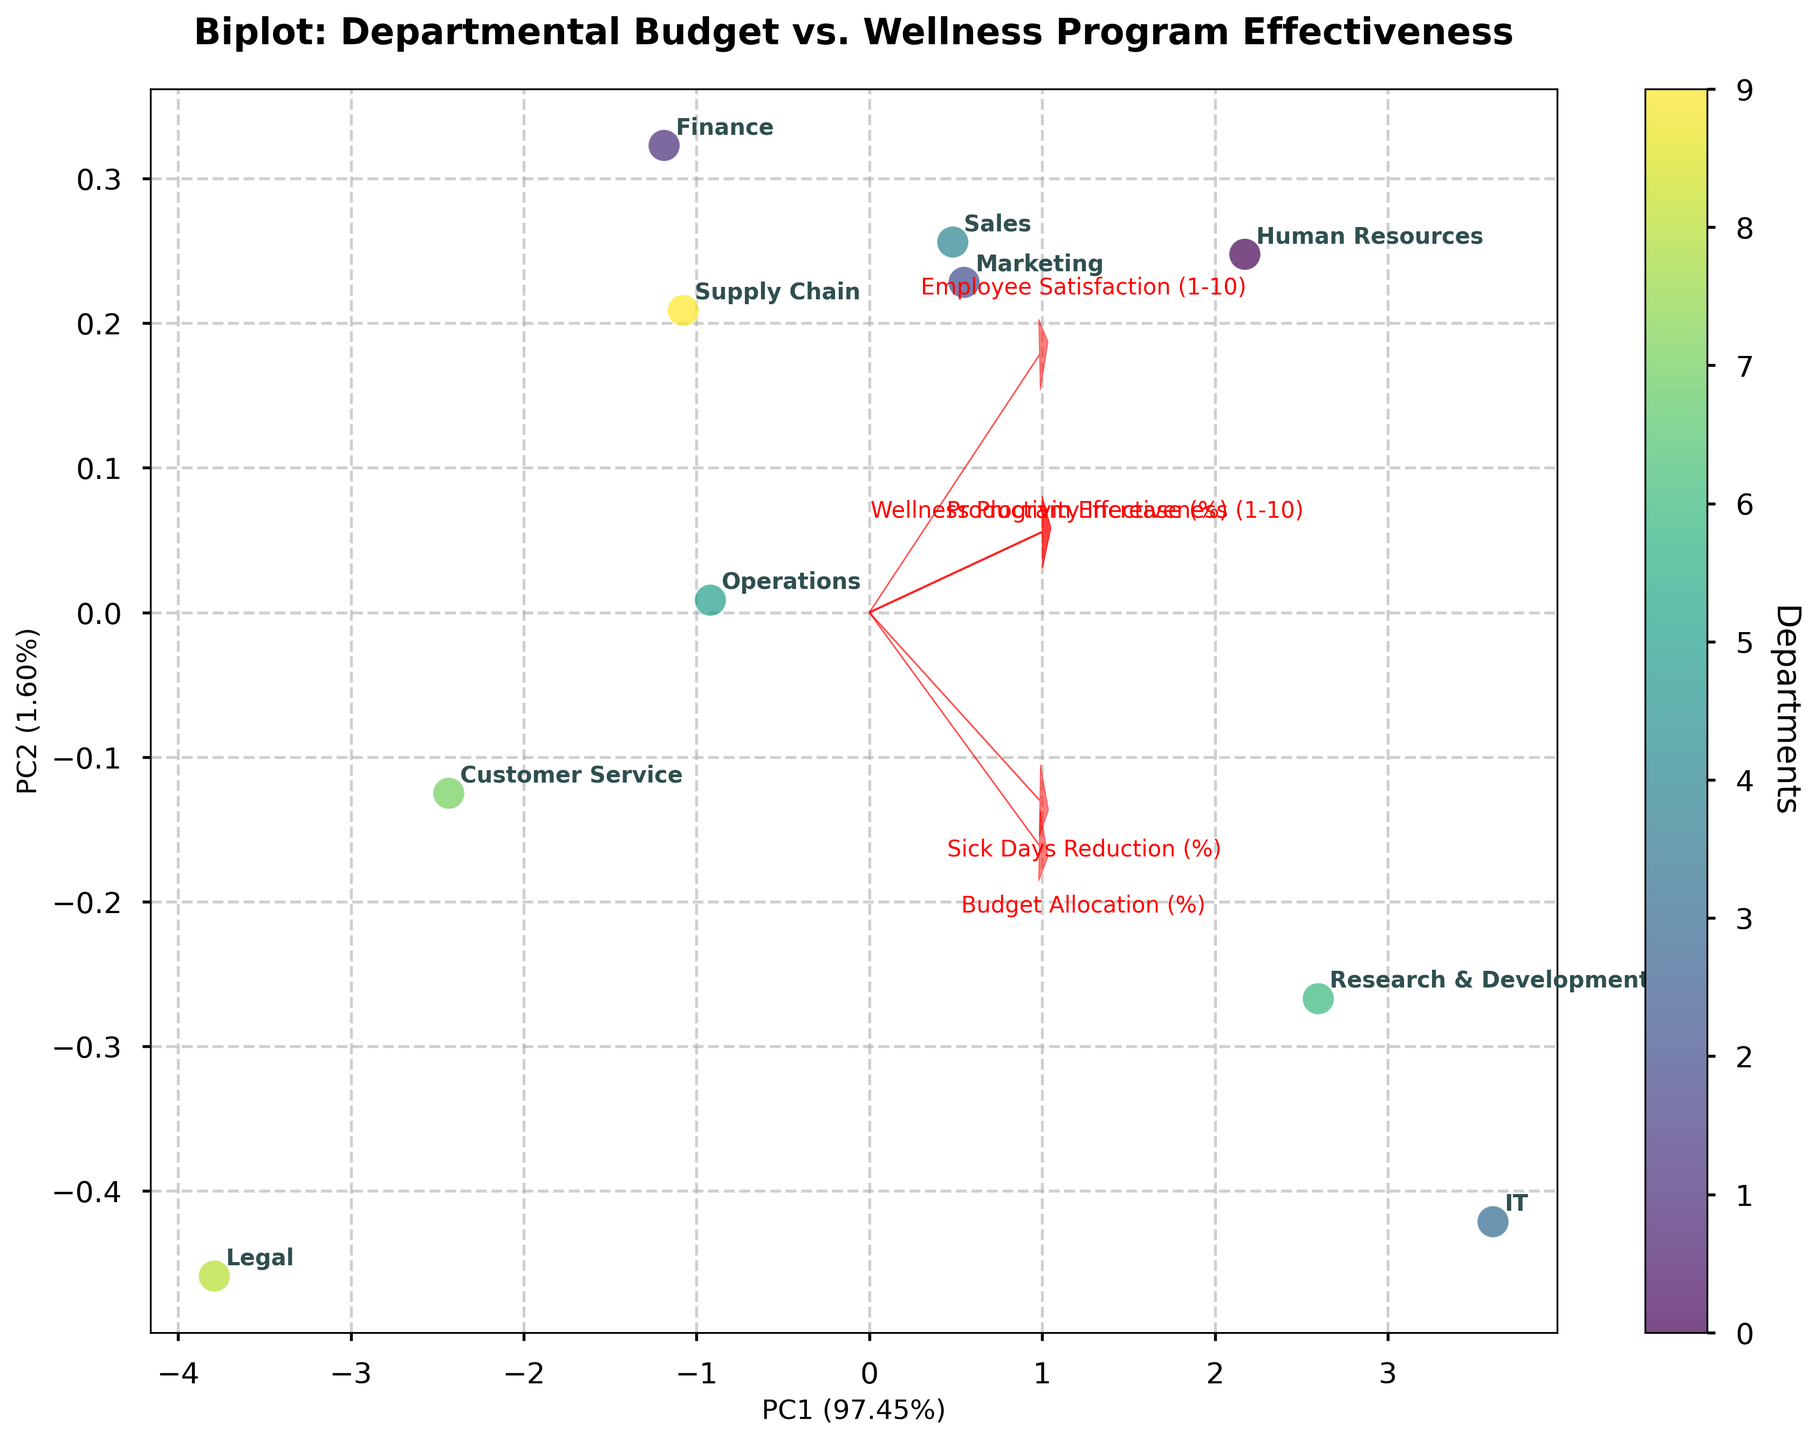What is the title of the figure? The title is written at the top of the figure and usually describes what the figure is about. In this case, the title states the relationship between Departmental Budget and Wellness Program Effectiveness.
Answer: Biplot: Departmental Budget vs. Wellness Program Effectiveness How many departments are represented in the figure? The figure displays labels for each department and has individual points for each one. By counting these labels or points, we can determine the number of departments.
Answer: 10 Which department has the highest Budget Allocation? We look for the department label closest to the loading vector pointing towards the highest value of Budget Allocation on the biplot.
Answer: IT Which two departments have similar Wellness Program Effectiveness scores? This can be identified by finding departments with labels placed close to each other along the loading vector associated with Wellness Program Effectiveness.
Answer: Human Resources and Research & Development Which department is linked to the highest Employee Satisfaction? We need to locate the department label that is closest to the loading vector pointing towards the highest Employee Satisfaction in the biplot.
Answer: IT How does Employee Satisfaction relate to Productivity Increase according to the loadings? By observing the direction and magnitude of the loading vectors for Employee Satisfaction and Productivity Increase, we can infer the relationship between these two variables. They will either point in a similar direction (positive correlation) or opposite directions (negative correlation).
Answer: Positive correlation Which department appears to be the most distinct in terms of all measured variables? The most distinct department will be the one whose point is furthest from the origin and others in the biplot, indicating it has higher or lower scores in several variables.
Answer: IT Are the departments with higher Budget Allocation generally more effective in their Wellness Programs? By looking at the distribution of departments along the vectors for Budget Allocation and Wellness Program Effectiveness, we can establish a pattern or trend.
Answer: Yes, generally What percentage of the total variance is explained by the first principal component (PC1)? This information is displayed on the x-axis label, where percentage of variance explained by PC1 is mentioned.
Answer: 50% How do Sick Days Reduction and Wellness Program Effectiveness relate across departments? This can be inferred by observing the directions and relationships of the department points along the loading vectors for both Sick Days Reduction and Wellness Program Effectiveness.
Answer: Positive correlation 